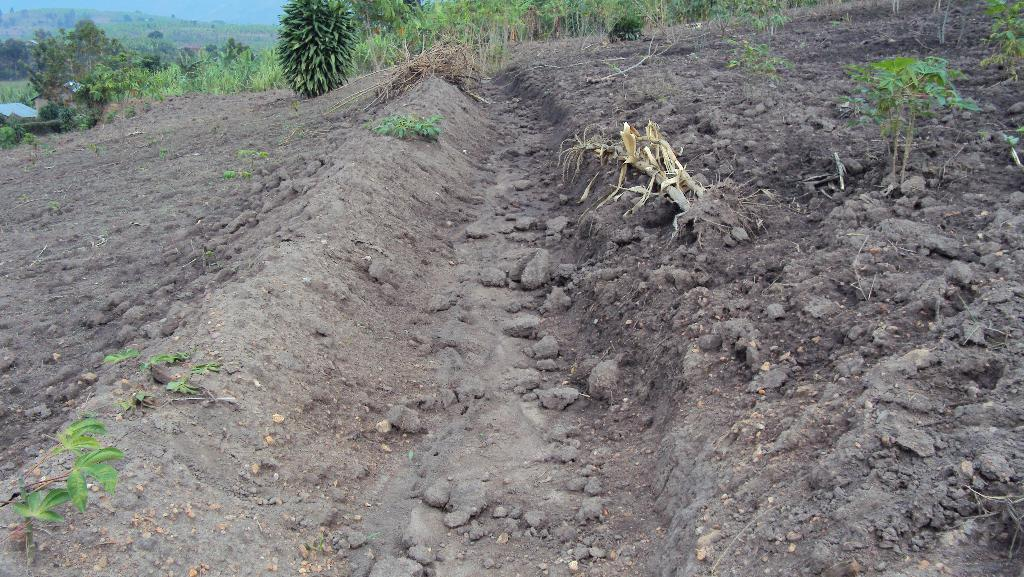What type of surface is visible in the image? There is soil in the image. What is growing on the soil in the image? There are plants on the ground in the image. What can be seen in the distance in the image? There are trees in the background of the image. What is visible above the trees in the image? The sky is visible in the background of the image. What type of bells can be heard ringing in the image? There are no bells present in the image, and therefore no sound can be heard. 